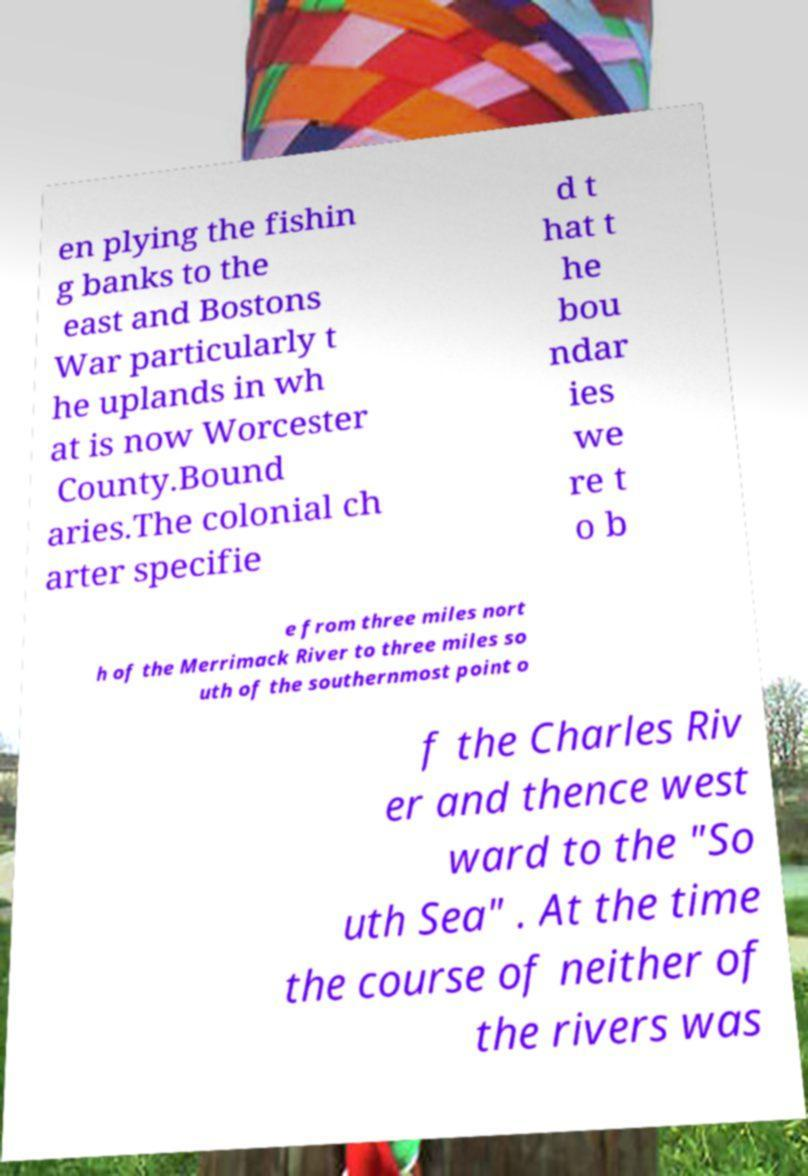I need the written content from this picture converted into text. Can you do that? en plying the fishin g banks to the east and Bostons War particularly t he uplands in wh at is now Worcester County.Bound aries.The colonial ch arter specifie d t hat t he bou ndar ies we re t o b e from three miles nort h of the Merrimack River to three miles so uth of the southernmost point o f the Charles Riv er and thence west ward to the "So uth Sea" . At the time the course of neither of the rivers was 